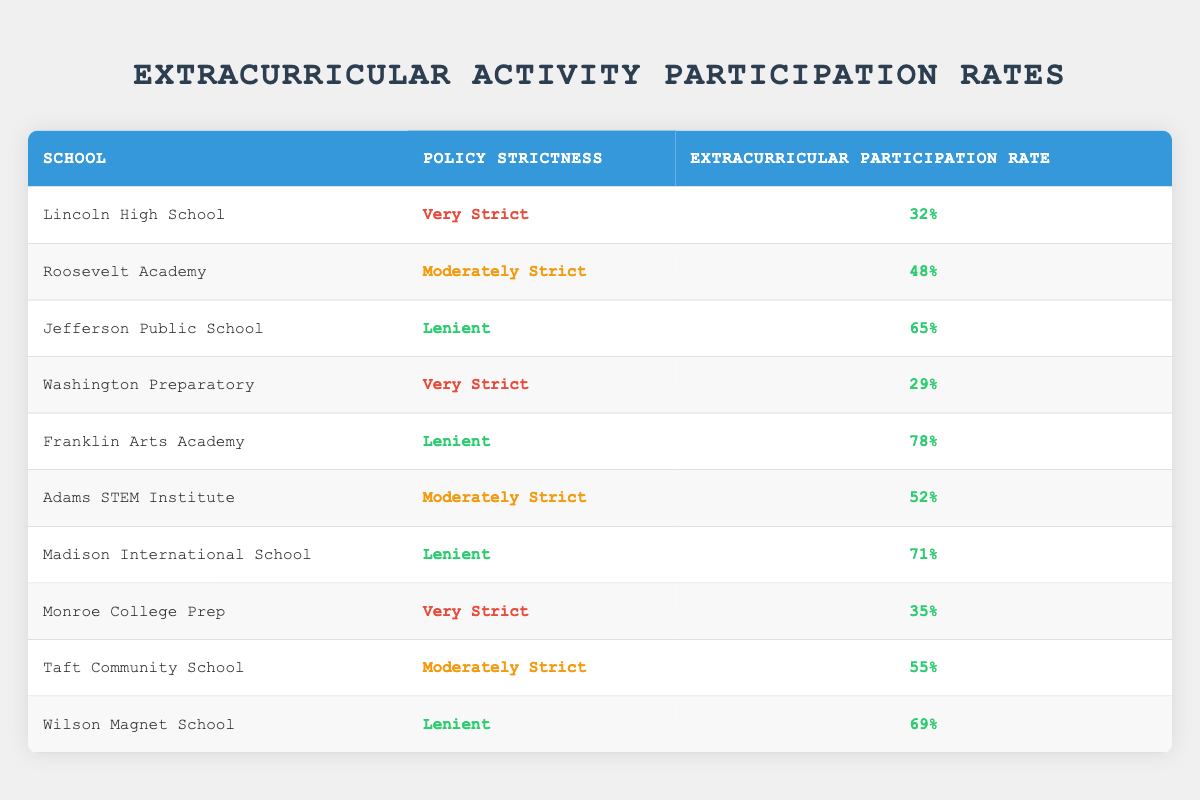What is the extracurricular participation rate at Jefferson Public School? The table shows that Jefferson Public School has an extracurricular participation rate of 65%.
Answer: 65% Which school has the highest extracurricular participation rate? Upon reviewing the data, Franklin Arts Academy has the highest participation rate at 78%.
Answer: 78% Is the extracurricular participation rate at Lincoln High School greater than 30%? The table indicates that Lincoln High School has a participation rate of 32%, which is indeed greater than 30%.
Answer: Yes How many schools have a lenient policy and what is their average participation rate? The schools with a lenient policy are Jefferson Public School (65%), Franklin Arts Academy (78%), Madison International School (71%), and Wilson Magnet School (69%). Adding these rates gives a total of 283%. There are 4 schools, so the average is 283% divided by 4, which equals 70.75%.
Answer: 70.75% Is Roosevelt Academy's participation rate the same as Taft Community School's? Roosevelt Academy has a participation rate of 48%, while Taft Community School has a rate of 55%. Therefore, they are not the same.
Answer: No What is the difference in participation rates between the very strict schools and the lenient schools? The very strict schools are Lincoln High School (32%), Washington Preparatory (29%), and Monroe College Prep (35%). The average participation rate for these schools is (32 + 29 + 35) / 3 = 32%. The lenient schools have an average participation rate of 70.75% (calculated previously). The difference is 70.75% - 32% = 38.75%.
Answer: 38.75% How many schools have a moderately strict policy, and what is the highest participation rate among them? The schools with a moderately strict policy are Roosevelt Academy (48%), Adams STEM Institute (52%), and Taft Community School (55%). There are 3 such schools, and the highest participation rate is 55% from Taft Community School.
Answer: 55% Do any lenient schools have a participation rate below 70%? The lenient schools listed are Jefferson Public School (65%), Franklin Arts Academy (78%), Madison International School (71%), and Wilson Magnet School (69%). Among these, Jefferson has a participation rate of 65%, which is below 70%.
Answer: Yes What is the total participation rate for all very strict schools? The very strict schools are Lincoln High School (32%), Washington Preparatory (29%), and Monroe College Prep (35%). The total participation rate is 32% + 29% + 35% = 96%.
Answer: 96% 